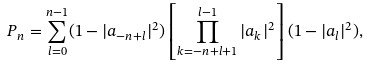<formula> <loc_0><loc_0><loc_500><loc_500>P _ { n } = \sum ^ { n - 1 } _ { l = 0 } ( 1 - | a _ { - n + l } | ^ { 2 } ) \left [ \prod ^ { l - 1 } _ { k = - n + l + 1 } | a _ { k } | ^ { 2 } \right ] ( 1 - | a _ { l } | ^ { 2 } ) ,</formula> 